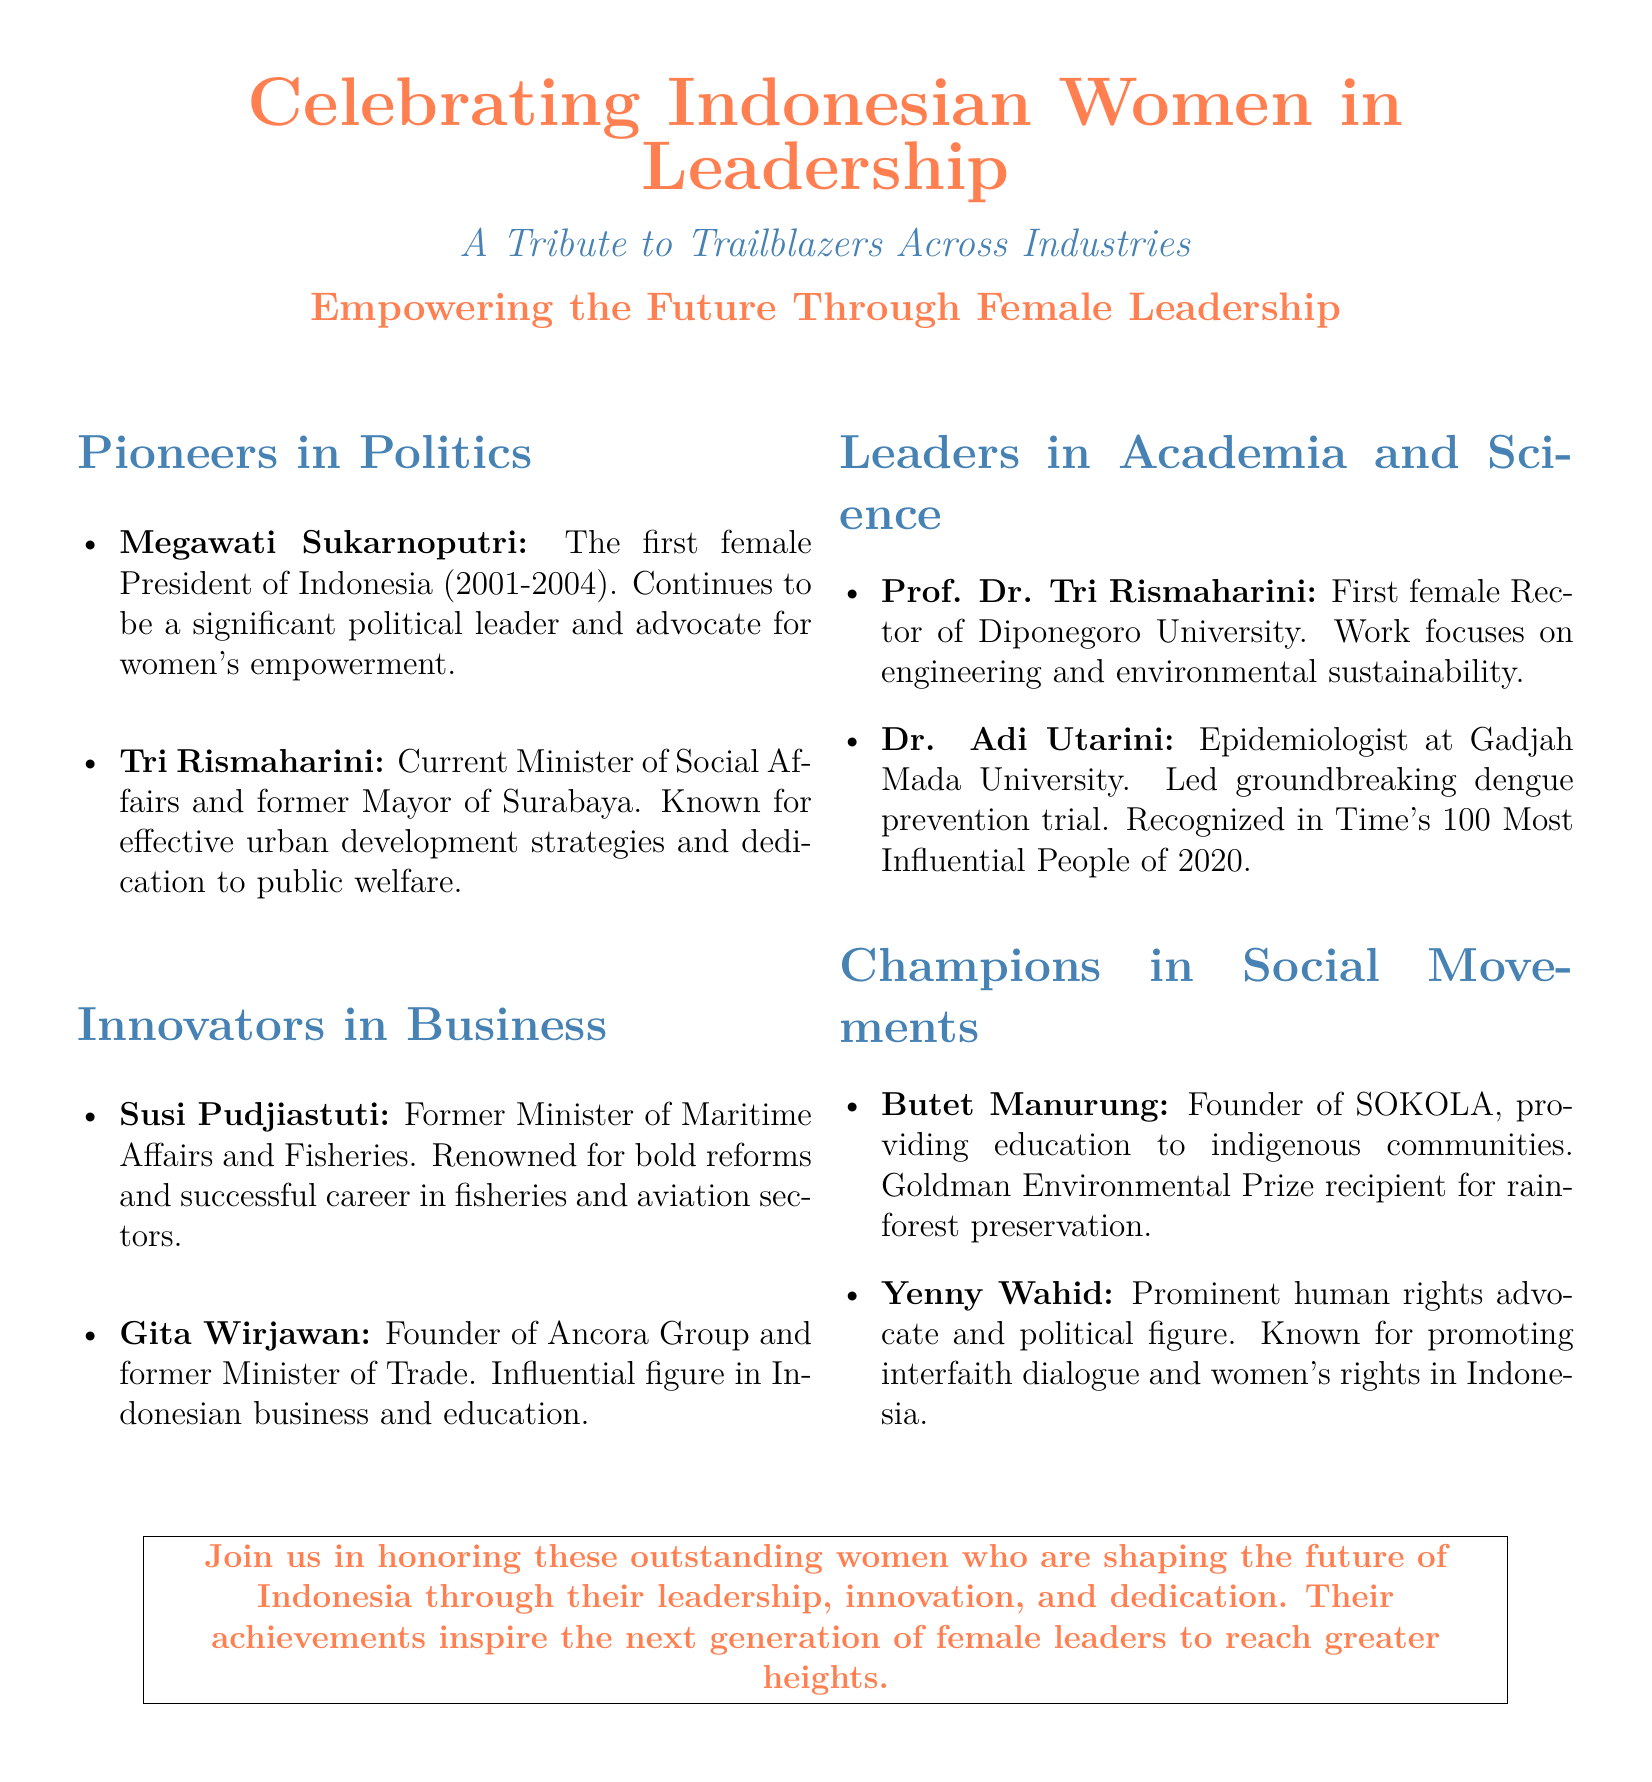What is the main theme of the flyer? The main theme is celebrating the contributions of Indonesian women in leadership across various industries.
Answer: Celebrating Indonesian Women in Leadership Who was the first female President of Indonesia? The document lists Megawati Sukarnoputri as the first female President of Indonesia.
Answer: Megawati Sukarnoputri Which current position does Tri Rismaharini hold? The document states she is the current Minister of Social Affairs.
Answer: Minister of Social Affairs What significant achievement is Dr. Adi Utarini known for? She is recognized for leading a groundbreaking dengue prevention trial.
Answer: Groundbreaking dengue prevention trial Which champion in social movements founded SOKOLA? Butet Manurung is mentioned as the founder of SOKOLA.
Answer: Butet Manurung What is the purpose of this flyer? The flyer aims to honor and recognize outstanding women leaders in Indonesia.
Answer: Honor and recognize outstanding women leaders How many areas of impact are highlighted in the document? Four areas of impact are specified: Politics, Business, Academia & Science, and Social Movements.
Answer: Four Who is recognized in Time's 100 Most Influential People of 2020? The document indicates that Dr. Adi Utarini is recognized in that list.
Answer: Dr. Adi Utarini 